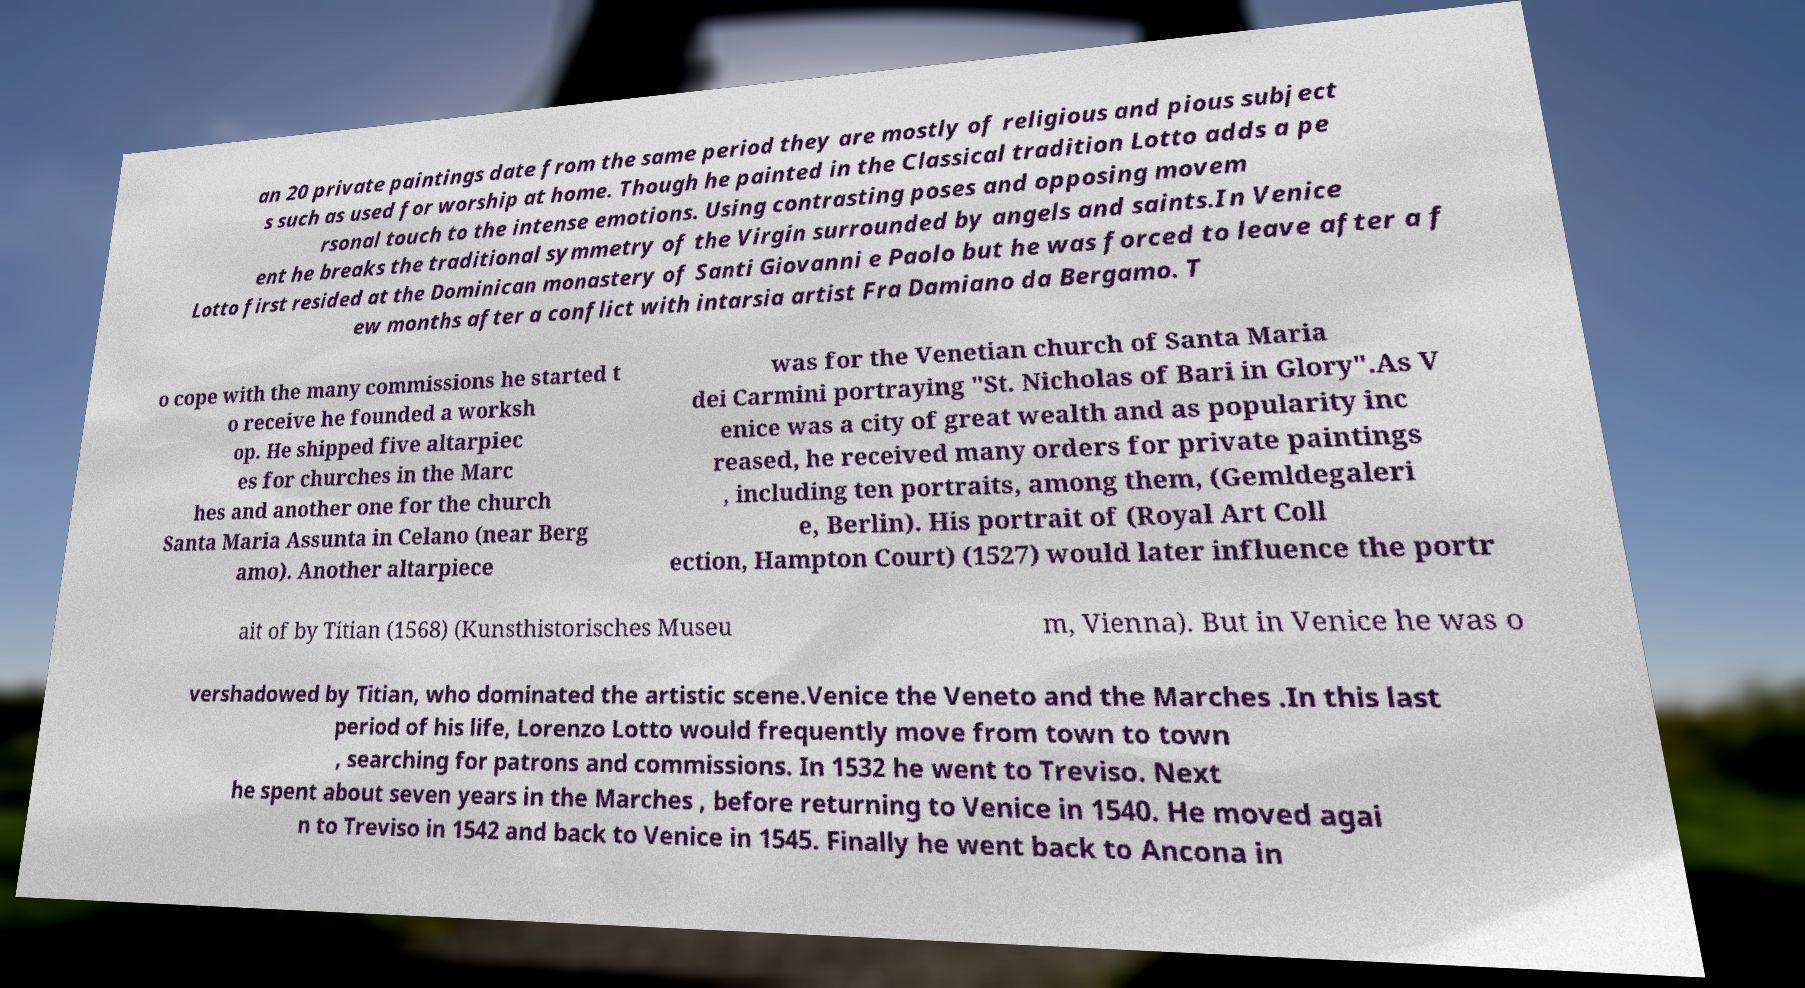What messages or text are displayed in this image? I need them in a readable, typed format. an 20 private paintings date from the same period they are mostly of religious and pious subject s such as used for worship at home. Though he painted in the Classical tradition Lotto adds a pe rsonal touch to the intense emotions. Using contrasting poses and opposing movem ent he breaks the traditional symmetry of the Virgin surrounded by angels and saints.In Venice Lotto first resided at the Dominican monastery of Santi Giovanni e Paolo but he was forced to leave after a f ew months after a conflict with intarsia artist Fra Damiano da Bergamo. T o cope with the many commissions he started t o receive he founded a worksh op. He shipped five altarpiec es for churches in the Marc hes and another one for the church Santa Maria Assunta in Celano (near Berg amo). Another altarpiece was for the Venetian church of Santa Maria dei Carmini portraying "St. Nicholas of Bari in Glory".As V enice was a city of great wealth and as popularity inc reased, he received many orders for private paintings , including ten portraits, among them, (Gemldegaleri e, Berlin). His portrait of (Royal Art Coll ection, Hampton Court) (1527) would later influence the portr ait of by Titian (1568) (Kunsthistorisches Museu m, Vienna). But in Venice he was o vershadowed by Titian, who dominated the artistic scene.Venice the Veneto and the Marches .In this last period of his life, Lorenzo Lotto would frequently move from town to town , searching for patrons and commissions. In 1532 he went to Treviso. Next he spent about seven years in the Marches , before returning to Venice in 1540. He moved agai n to Treviso in 1542 and back to Venice in 1545. Finally he went back to Ancona in 